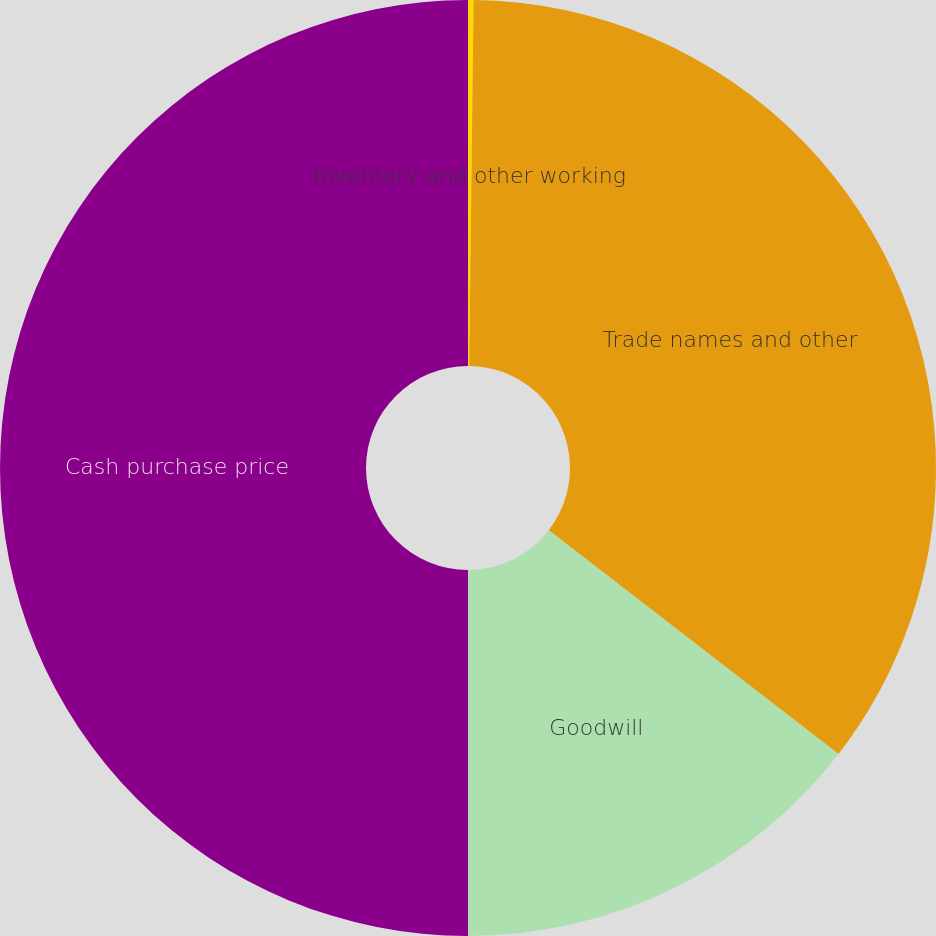Convert chart to OTSL. <chart><loc_0><loc_0><loc_500><loc_500><pie_chart><fcel>Inventory and other working<fcel>Trade names and other<fcel>Goodwill<fcel>Cash purchase price<nl><fcel>0.19%<fcel>35.27%<fcel>14.54%<fcel>50.0%<nl></chart> 